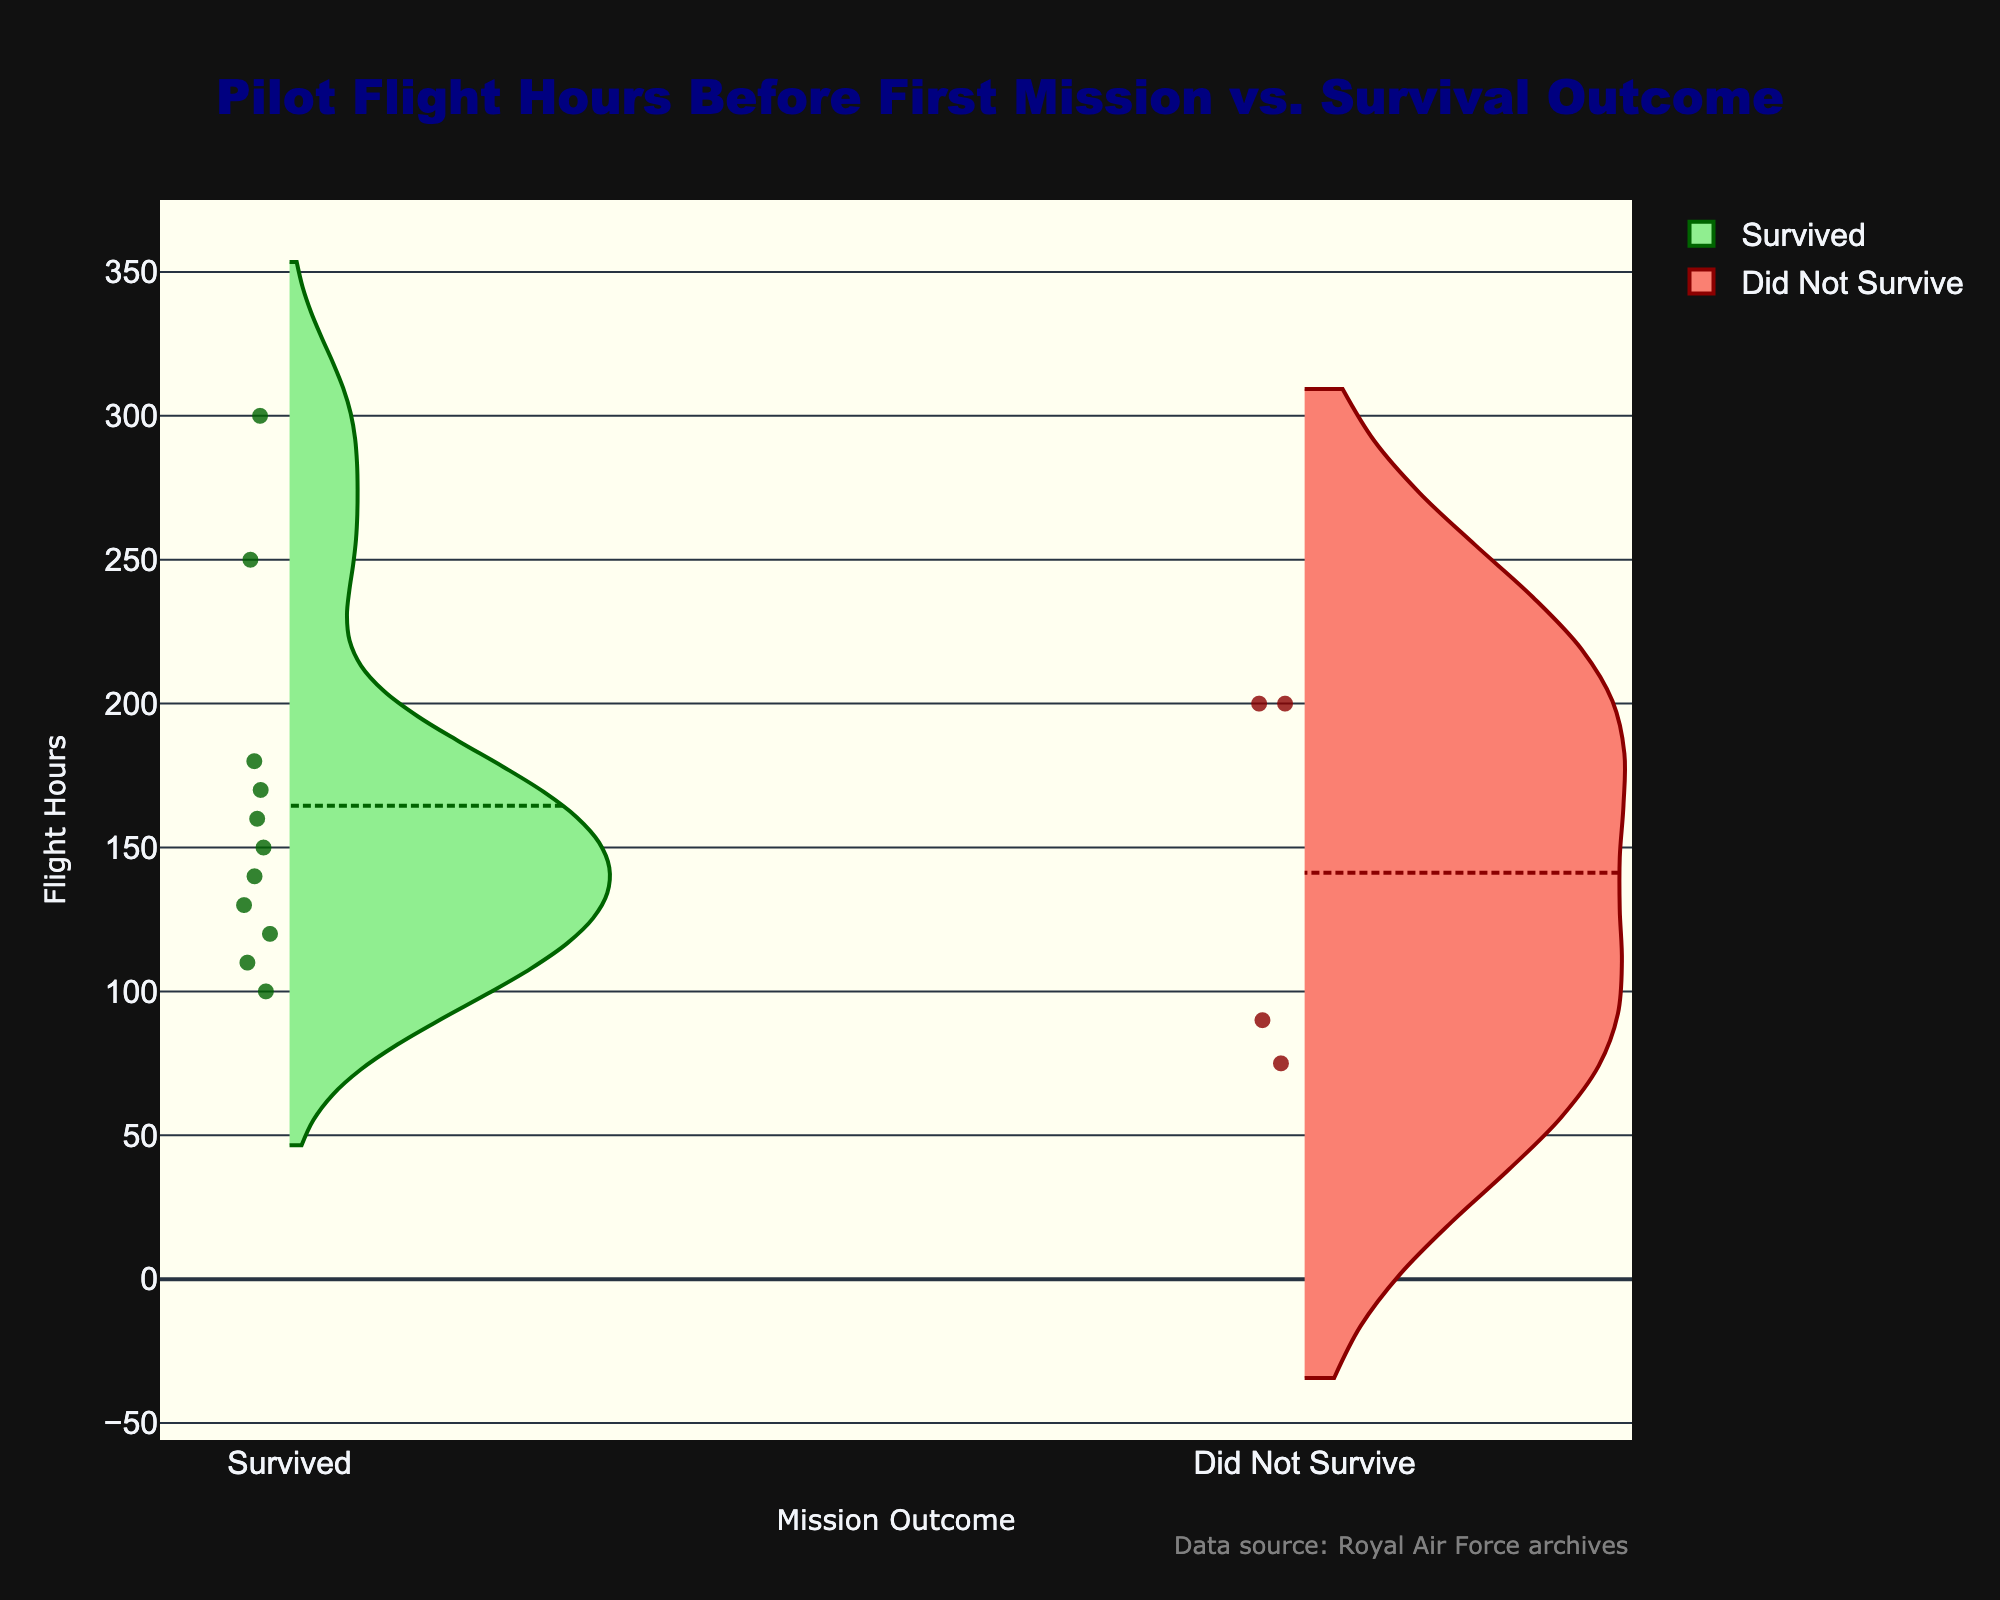what is the title of the chart? The title is usually placed at the top of the chart and summarizes the data being presented. In this figure, the title reads "Pilot Flight Hours Before First Mission vs. Survival Outcome".
Answer: Pilot Flight Hours Before First Mission vs. Survival Outcome What are the x-axis labels in the chart? The x-axis labels correspond to the categories of data being represented. In this case, the x-axis labels are "Survived" and "Did Not Survive".
Answer: Survived, Did Not Survive How many pilots survived their first mission? The data points for "Survived" are plotted on the left side of the chart. By counting the individual data points within the "Survived" category, you can see that there are 11 pilots who survived.
Answer: 11 How many pilots did not survive their first mission? Similar to the previous question, you count the data points under the "Did Not Survive" category. There are 3 pilots in this category.
Answer: 3 Which group has a higher median flight hours before their first mission? For both "Survived" and "Did Not Survive" groups, the median is the horizontal line within each violin plot. By comparing these lines, you can see that the median for the "Survived" group is higher.
Answer: Survived What is the general range of flight hours for those who did not survive their first mission? Observing the "Did Not Survive" side of the chart, you can see the distribution stretched from about 75 to 200 flight hours.
Answer: 75 to 200 What color represents the "Survived" category in the chart? Colors help distinguish different categories in the chart. The "Survived" category is represented by shades of green, specifically dark green for the line and light green for the filled area.
Answer: green Which group shows a wider spread of flight hours before their first mission? The spread of a violin plot indicates the range of data values. The "Survived" group exhibits a wider spread of flight hours compared to the "Did Not Survive" group.
Answer: Survived Are there any pilots who had exactly 200 flight hours before their first mission? Check both sides of the chart for data points exactly at the 200 flight hours mark. There are such points on both the "Survived" and "Did Not Survive" sides.
Answer: Yes What is the mean flight hours of pilots in the "Did Not Survive" group? The mean is indicated by the central horizontal line in each violin plot with a marker. For the "Did Not Survive" group, it's around the middle of the range, likely close to 125 hours.
Answer: 125 